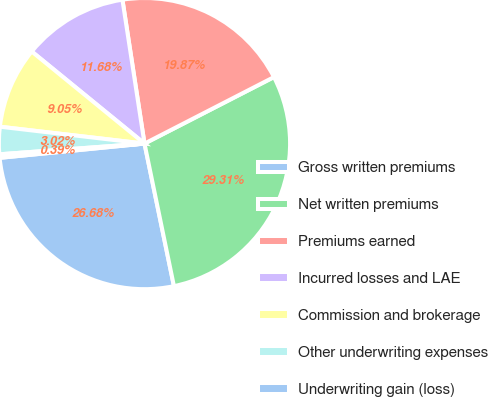<chart> <loc_0><loc_0><loc_500><loc_500><pie_chart><fcel>Gross written premiums<fcel>Net written premiums<fcel>Premiums earned<fcel>Incurred losses and LAE<fcel>Commission and brokerage<fcel>Other underwriting expenses<fcel>Underwriting gain (loss)<nl><fcel>26.68%<fcel>29.31%<fcel>19.87%<fcel>11.68%<fcel>9.05%<fcel>3.02%<fcel>0.39%<nl></chart> 